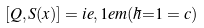Convert formula to latex. <formula><loc_0><loc_0><loc_500><loc_500>[ Q , S ( x ) ] = i e , 1 e m ( \hbar { = } 1 = c )</formula> 